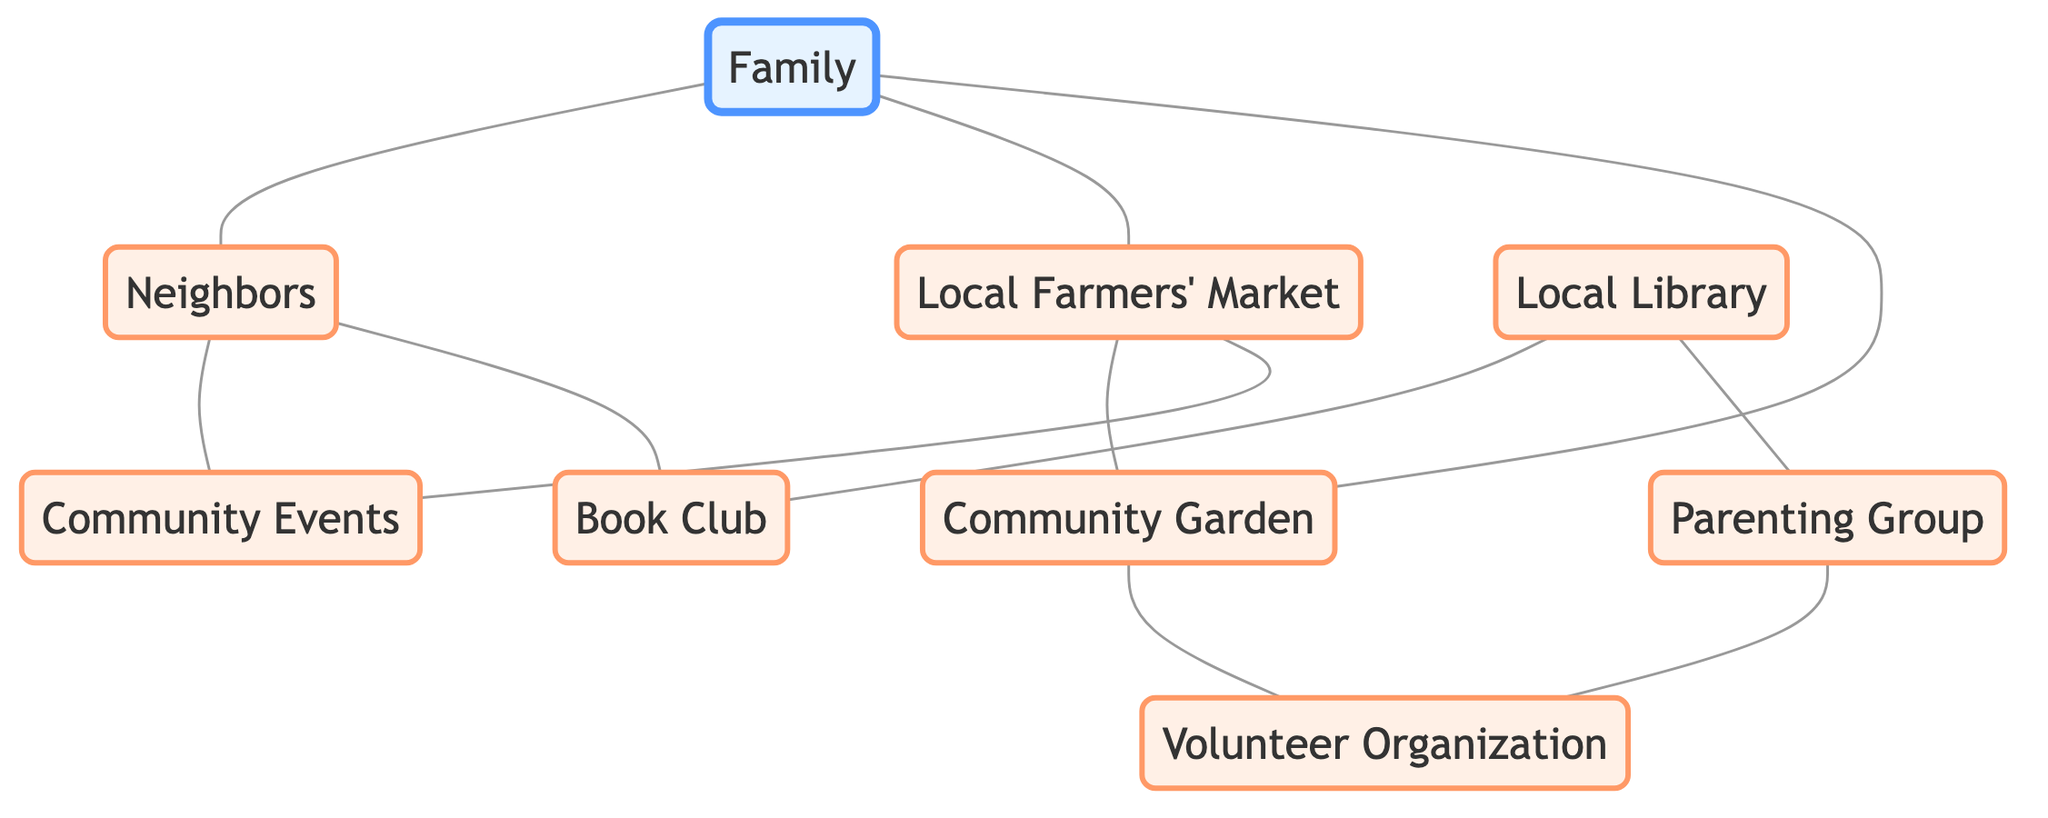What are the total number of nodes in the diagram? To find the total number of nodes, we count each unique entry in the "nodes" section. There are 9 distinct nodes listed: Family, Neighbors, Local Farmers' Market, Community Garden, Local Library, Parenting Group, Volunteer Organization, Book Club, and Community Events.
Answer: 9 Which nodes are directly connected to "Family"? By examining the edges connected to "Family," we can see that it has three direct connections: Neighbors, Local Farmers' Market, and Community Garden.
Answer: Neighbors, Local Farmers' Market, Community Garden How many edges are there in total? To find the total number of edges, we count each connection listed in the "edges" section, which includes all the directed relationships between nodes. There are 10 distinct edges shown.
Answer: 10 What is the relationship between "Local Library" and "Book Club"? The relationship is established by a direct connection in the edges section pointing from "Local Library" to "Book Club." This indicates that they are connected, with "Local Library" likely offering resources or meetings for the "Book Club."
Answer: Directly connected Which node is linked to both "Neighbors" and "Community Garden"? "Local Farmers' Market" is linked to both "Neighbors" through the edge connecting to "Community Events" and also directly connected to "Community Garden." This node acts as a point of connection for both.
Answer: Local Farmers' Market How many nodes connect to "Volunteer Organization"? "Volunteer Organization" connects to two nodes: "Community Garden" and "Parenting Group." By analyzing the edges that point to "Volunteer Organization," it is clear that there are two connections.
Answer: 2 What serves as a connecting node between "Community Garden" and "Local Farmers' Market"? "Local Farmers' Market" serves as the connecting node between "Community Garden" and itself, as there is an edge from "Local Farmers' Market" to "Community Garden." This shows that both are linked through this node.
Answer: Local Farmers' Market What type of community activity does "Parenting Group" connect with? "Parenting Group" connects with "Volunteer Organization," indicating that the activities associated with parenting can also be tied into broader volunteer efforts within the community.
Answer: Volunteer Organization How many community-related nodes are there? The community-related nodes are Neighbors, Local Farmers' Market, Community Garden, Local Library, Parenting Group, Volunteer Organization, Book Club, and Community Events. Counting these, we find there are 8 community-related nodes.
Answer: 8 